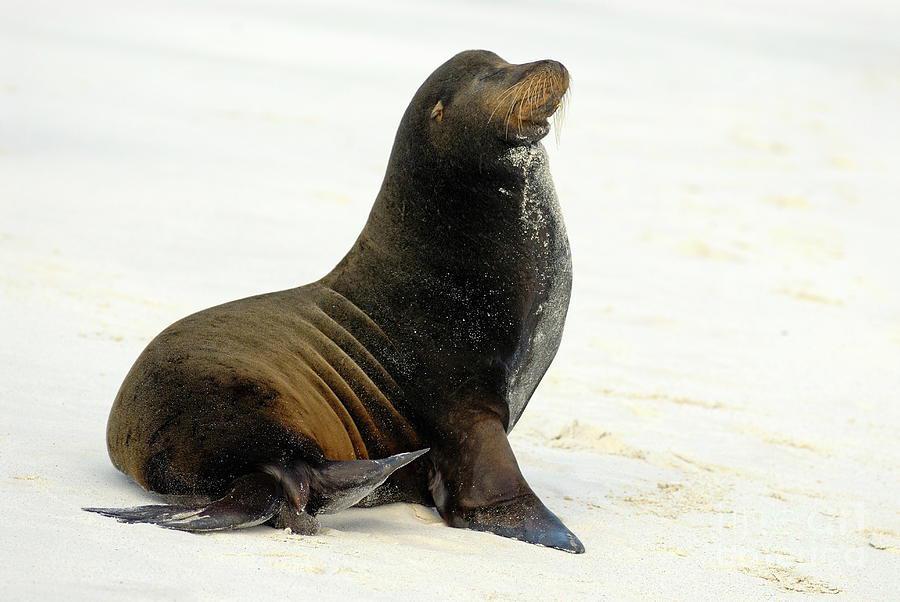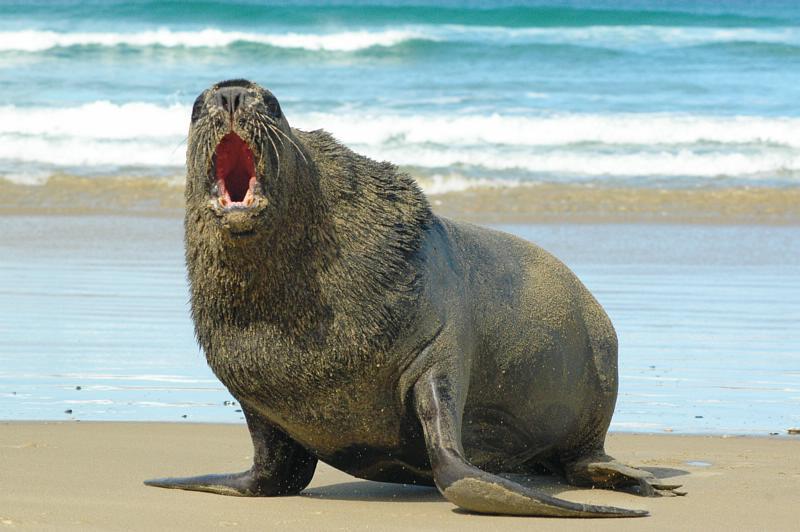The first image is the image on the left, the second image is the image on the right. Evaluate the accuracy of this statement regarding the images: "The seals in the right and left images have their bodies turned in different [left vs right] directions, and no seals shown are babies.". Is it true? Answer yes or no. Yes. The first image is the image on the left, the second image is the image on the right. For the images shown, is this caption "There is one seal with a plain white background." true? Answer yes or no. Yes. 